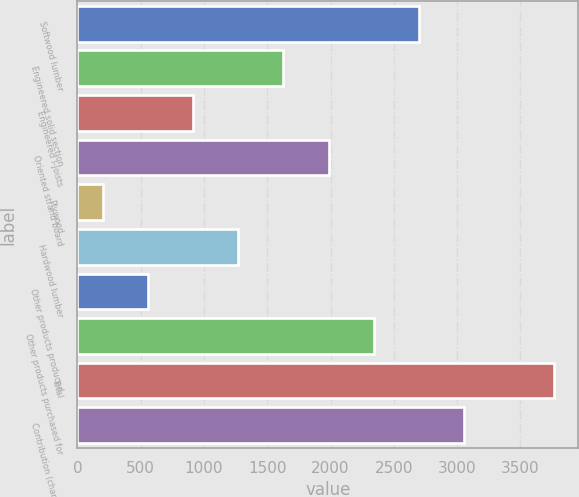Convert chart. <chart><loc_0><loc_0><loc_500><loc_500><bar_chart><fcel>Softwood lumber<fcel>Engineered solid section<fcel>Engineered I-joists<fcel>Oriented strand board<fcel>Plywood<fcel>Hardwood lumber<fcel>Other products produced<fcel>Other products purchased for<fcel>Total<fcel>Contribution (charge) to<nl><fcel>2698.2<fcel>1628.4<fcel>915.2<fcel>1985<fcel>202<fcel>1271.8<fcel>558.6<fcel>2341.6<fcel>3768<fcel>3054.8<nl></chart> 